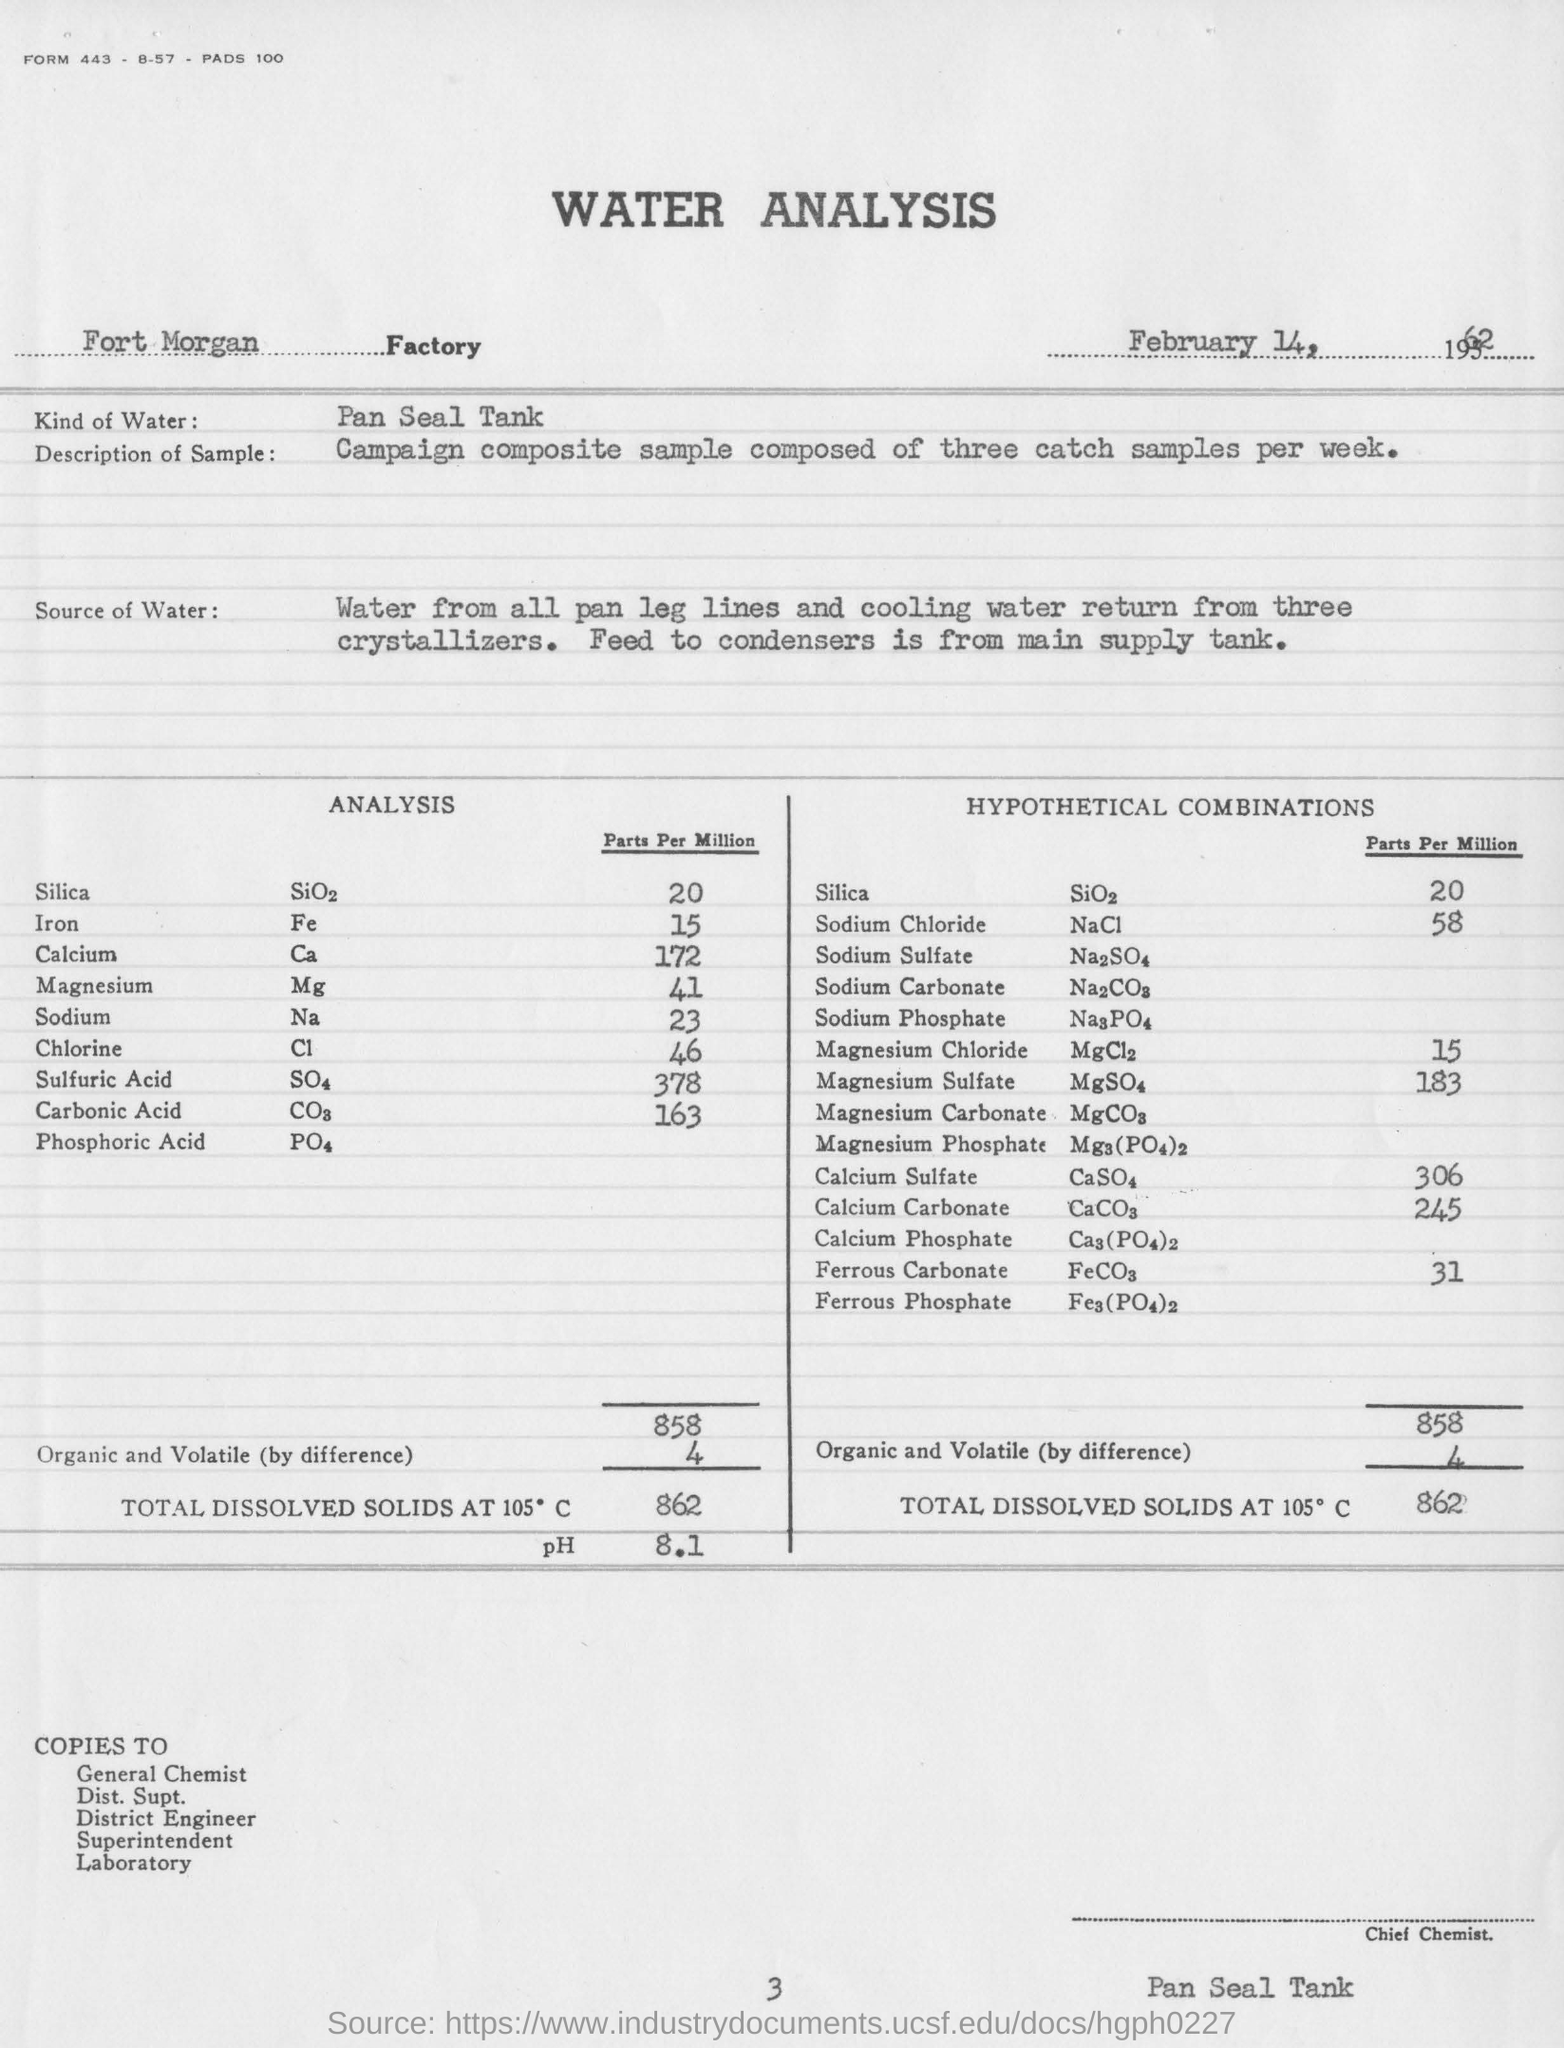How much is the Iron rate in the analysis report?
Your answer should be compact. 15 Parts Per Million. What is the pH value mentioned in the analysis
Offer a terse response. 8.1. 